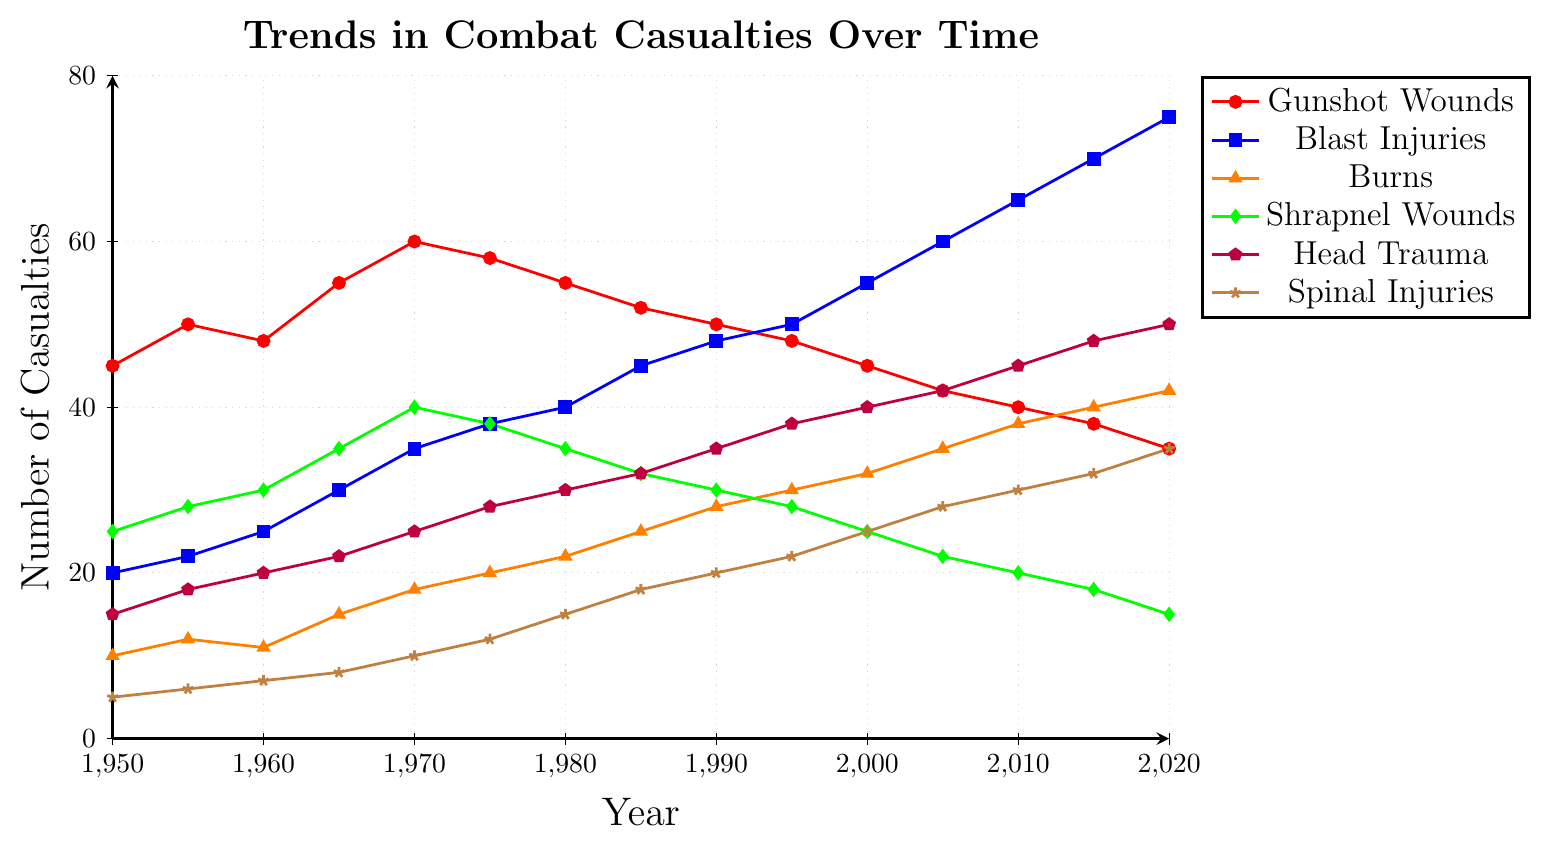What's the trend in the number of Gunshot Wounds from 1950 to 2020? Gunshot Wounds initially increased from 45 in 1950 to 60 in 1970, then gradually decreased to 35 by 2020.
Answer: Initially increased, then decreased Which injury type increased the most over the period from 1950 to 2020? Blast Injuries increased from 20 in 1950 to 75 in 2020, showing the largest increase among the injury types.
Answer: Blast Injuries What is the difference in the number of Shrapnel Wounds between 1970 and 2020? In 1970, there were 40 Shrapnel Wounds, and in 2020, there were 15. The difference is 40 - 15 = 25.
Answer: 25 Between 2000 and 2010, which injury type saw the largest increase? Blast Injuries increased from 55 in 2000 to 65 in 2010, which is an increase of 10, the largest increase among all injury types for that period.
Answer: Blast Injuries Considering the trend from 1950 to 2020, predict if the number of Spinal Injuries will keep increasing, decreasing, or stay the same. Spinal Injuries show a consistent increase from 1950 (5) to 2020 (35), indicating a likely continuing increase.
Answer: Increasing Compare the trends of Head Trauma and Burns from 1950 to 2020. Head Trauma increased steadily from 15 in 1950 to 50 in 2020. Burns also increased steadily from 10 in 1950 to 42 in 2020, but at a slightly slower rate.
Answer: Both increased, more rapidly for Head Trauma What is the combined number of casualties from all injury types in 1975? Summing 1975 data: Gunshot Wounds (58) + Blast Injuries (38) + Burns (20) + Shrapnel Wounds (38) + Head Trauma (28) + Spinal Injuries (12) = 194.
Answer: 194 How did the trend of Shrapnel Wounds change compared to Gunshot Wounds from 1980 to 2020? Shrapnel Wounds decreased from 35 in 1980 to 15 in 2020, while Gunshot Wounds decreased from 55 in 1980 to 35 in 2020. Both decreased, but Shrapnel Wounds had a steeper decline.
Answer: Both decreased, Shrapnel Wounds more steeply Identify the year where the number of Blast Injuries surpassed the number of Gunshot Wounds. In 2000, Blast Injuries (55) surpassed Gunshot Wounds (45) for the first time.
Answer: 2000 What is the average number of casualties for Spinal Injuries over the entire period? Sum all Spinal Injuries data from 1950 to 2020: (5 + 6 + 7 + 8 + 10 + 12 + 15 + 18 + 20 + 22 + 25 + 28 + 30 + 32 + 35) = 273. There are 15 data points, so the average is 273 / 15 = 18.2.
Answer: 18.2 